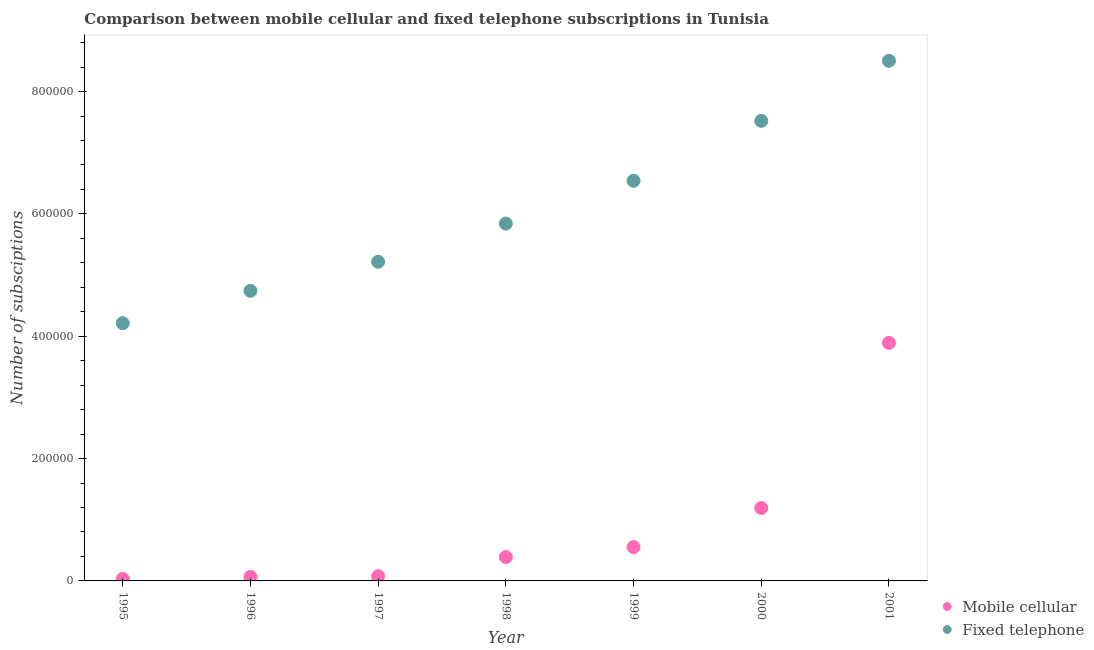What is the number of mobile cellular subscriptions in 1995?
Provide a short and direct response. 3185. Across all years, what is the maximum number of fixed telephone subscriptions?
Provide a succinct answer. 8.50e+05. Across all years, what is the minimum number of fixed telephone subscriptions?
Ensure brevity in your answer.  4.21e+05. In which year was the number of mobile cellular subscriptions minimum?
Your answer should be compact. 1995. What is the total number of fixed telephone subscriptions in the graph?
Make the answer very short. 4.26e+06. What is the difference between the number of mobile cellular subscriptions in 1998 and that in 2001?
Provide a short and direct response. -3.50e+05. What is the difference between the number of fixed telephone subscriptions in 1997 and the number of mobile cellular subscriptions in 1998?
Your answer should be compact. 4.83e+05. What is the average number of mobile cellular subscriptions per year?
Offer a very short reply. 8.86e+04. In the year 2000, what is the difference between the number of fixed telephone subscriptions and number of mobile cellular subscriptions?
Provide a succinct answer. 6.33e+05. In how many years, is the number of fixed telephone subscriptions greater than 200000?
Your answer should be very brief. 7. What is the ratio of the number of fixed telephone subscriptions in 1997 to that in 2000?
Your answer should be compact. 0.69. Is the number of mobile cellular subscriptions in 1997 less than that in 1998?
Give a very brief answer. Yes. Is the difference between the number of mobile cellular subscriptions in 1995 and 2000 greater than the difference between the number of fixed telephone subscriptions in 1995 and 2000?
Your response must be concise. Yes. What is the difference between the highest and the second highest number of fixed telephone subscriptions?
Keep it short and to the point. 9.82e+04. What is the difference between the highest and the lowest number of mobile cellular subscriptions?
Your answer should be very brief. 3.86e+05. Is the sum of the number of mobile cellular subscriptions in 1995 and 2001 greater than the maximum number of fixed telephone subscriptions across all years?
Provide a short and direct response. No. Does the graph contain grids?
Provide a succinct answer. No. Where does the legend appear in the graph?
Offer a terse response. Bottom right. What is the title of the graph?
Offer a terse response. Comparison between mobile cellular and fixed telephone subscriptions in Tunisia. Does "Services" appear as one of the legend labels in the graph?
Provide a succinct answer. No. What is the label or title of the Y-axis?
Keep it short and to the point. Number of subsciptions. What is the Number of subsciptions in Mobile cellular in 1995?
Provide a succinct answer. 3185. What is the Number of subsciptions in Fixed telephone in 1995?
Your response must be concise. 4.21e+05. What is the Number of subsciptions of Mobile cellular in 1996?
Keep it short and to the point. 6500. What is the Number of subsciptions of Fixed telephone in 1996?
Keep it short and to the point. 4.74e+05. What is the Number of subsciptions of Mobile cellular in 1997?
Make the answer very short. 7656. What is the Number of subsciptions of Fixed telephone in 1997?
Keep it short and to the point. 5.22e+05. What is the Number of subsciptions of Mobile cellular in 1998?
Provide a short and direct response. 3.90e+04. What is the Number of subsciptions in Fixed telephone in 1998?
Ensure brevity in your answer.  5.84e+05. What is the Number of subsciptions in Mobile cellular in 1999?
Ensure brevity in your answer.  5.53e+04. What is the Number of subsciptions of Fixed telephone in 1999?
Your response must be concise. 6.54e+05. What is the Number of subsciptions in Mobile cellular in 2000?
Offer a very short reply. 1.19e+05. What is the Number of subsciptions in Fixed telephone in 2000?
Your answer should be very brief. 7.52e+05. What is the Number of subsciptions in Mobile cellular in 2001?
Ensure brevity in your answer.  3.89e+05. What is the Number of subsciptions in Fixed telephone in 2001?
Keep it short and to the point. 8.50e+05. Across all years, what is the maximum Number of subsciptions of Mobile cellular?
Your response must be concise. 3.89e+05. Across all years, what is the maximum Number of subsciptions in Fixed telephone?
Offer a terse response. 8.50e+05. Across all years, what is the minimum Number of subsciptions of Mobile cellular?
Make the answer very short. 3185. Across all years, what is the minimum Number of subsciptions in Fixed telephone?
Your answer should be very brief. 4.21e+05. What is the total Number of subsciptions of Mobile cellular in the graph?
Provide a short and direct response. 6.20e+05. What is the total Number of subsciptions of Fixed telephone in the graph?
Provide a short and direct response. 4.26e+06. What is the difference between the Number of subsciptions in Mobile cellular in 1995 and that in 1996?
Your response must be concise. -3315. What is the difference between the Number of subsciptions of Fixed telephone in 1995 and that in 1996?
Your answer should be compact. -5.29e+04. What is the difference between the Number of subsciptions of Mobile cellular in 1995 and that in 1997?
Your response must be concise. -4471. What is the difference between the Number of subsciptions of Fixed telephone in 1995 and that in 1997?
Give a very brief answer. -1.00e+05. What is the difference between the Number of subsciptions in Mobile cellular in 1995 and that in 1998?
Ensure brevity in your answer.  -3.58e+04. What is the difference between the Number of subsciptions of Fixed telephone in 1995 and that in 1998?
Give a very brief answer. -1.63e+05. What is the difference between the Number of subsciptions of Mobile cellular in 1995 and that in 1999?
Keep it short and to the point. -5.21e+04. What is the difference between the Number of subsciptions in Fixed telephone in 1995 and that in 1999?
Offer a terse response. -2.33e+05. What is the difference between the Number of subsciptions of Mobile cellular in 1995 and that in 2000?
Ensure brevity in your answer.  -1.16e+05. What is the difference between the Number of subsciptions of Fixed telephone in 1995 and that in 2000?
Provide a succinct answer. -3.31e+05. What is the difference between the Number of subsciptions in Mobile cellular in 1995 and that in 2001?
Your response must be concise. -3.86e+05. What is the difference between the Number of subsciptions of Fixed telephone in 1995 and that in 2001?
Your response must be concise. -4.29e+05. What is the difference between the Number of subsciptions in Mobile cellular in 1996 and that in 1997?
Offer a very short reply. -1156. What is the difference between the Number of subsciptions of Fixed telephone in 1996 and that in 1997?
Your response must be concise. -4.75e+04. What is the difference between the Number of subsciptions in Mobile cellular in 1996 and that in 1998?
Ensure brevity in your answer.  -3.25e+04. What is the difference between the Number of subsciptions of Fixed telephone in 1996 and that in 1998?
Provide a succinct answer. -1.10e+05. What is the difference between the Number of subsciptions of Mobile cellular in 1996 and that in 1999?
Keep it short and to the point. -4.88e+04. What is the difference between the Number of subsciptions of Fixed telephone in 1996 and that in 1999?
Your answer should be compact. -1.80e+05. What is the difference between the Number of subsciptions of Mobile cellular in 1996 and that in 2000?
Provide a short and direct response. -1.13e+05. What is the difference between the Number of subsciptions of Fixed telephone in 1996 and that in 2000?
Offer a terse response. -2.78e+05. What is the difference between the Number of subsciptions of Mobile cellular in 1996 and that in 2001?
Make the answer very short. -3.83e+05. What is the difference between the Number of subsciptions of Fixed telephone in 1996 and that in 2001?
Keep it short and to the point. -3.76e+05. What is the difference between the Number of subsciptions of Mobile cellular in 1997 and that in 1998?
Provide a short and direct response. -3.13e+04. What is the difference between the Number of subsciptions of Fixed telephone in 1997 and that in 1998?
Your answer should be very brief. -6.25e+04. What is the difference between the Number of subsciptions of Mobile cellular in 1997 and that in 1999?
Your answer should be compact. -4.76e+04. What is the difference between the Number of subsciptions of Fixed telephone in 1997 and that in 1999?
Provide a short and direct response. -1.32e+05. What is the difference between the Number of subsciptions of Mobile cellular in 1997 and that in 2000?
Keep it short and to the point. -1.12e+05. What is the difference between the Number of subsciptions in Fixed telephone in 1997 and that in 2000?
Keep it short and to the point. -2.30e+05. What is the difference between the Number of subsciptions in Mobile cellular in 1997 and that in 2001?
Give a very brief answer. -3.82e+05. What is the difference between the Number of subsciptions in Fixed telephone in 1997 and that in 2001?
Your answer should be very brief. -3.29e+05. What is the difference between the Number of subsciptions of Mobile cellular in 1998 and that in 1999?
Provide a short and direct response. -1.63e+04. What is the difference between the Number of subsciptions in Fixed telephone in 1998 and that in 1999?
Offer a very short reply. -7.00e+04. What is the difference between the Number of subsciptions in Mobile cellular in 1998 and that in 2000?
Make the answer very short. -8.02e+04. What is the difference between the Number of subsciptions in Fixed telephone in 1998 and that in 2000?
Your response must be concise. -1.68e+05. What is the difference between the Number of subsciptions of Mobile cellular in 1998 and that in 2001?
Provide a succinct answer. -3.50e+05. What is the difference between the Number of subsciptions in Fixed telephone in 1998 and that in 2001?
Provide a short and direct response. -2.66e+05. What is the difference between the Number of subsciptions in Mobile cellular in 1999 and that in 2000?
Your answer should be compact. -6.39e+04. What is the difference between the Number of subsciptions in Fixed telephone in 1999 and that in 2000?
Provide a short and direct response. -9.79e+04. What is the difference between the Number of subsciptions of Mobile cellular in 1999 and that in 2001?
Your answer should be compact. -3.34e+05. What is the difference between the Number of subsciptions in Fixed telephone in 1999 and that in 2001?
Offer a very short reply. -1.96e+05. What is the difference between the Number of subsciptions of Mobile cellular in 2000 and that in 2001?
Your response must be concise. -2.70e+05. What is the difference between the Number of subsciptions of Fixed telephone in 2000 and that in 2001?
Offer a very short reply. -9.82e+04. What is the difference between the Number of subsciptions of Mobile cellular in 1995 and the Number of subsciptions of Fixed telephone in 1996?
Give a very brief answer. -4.71e+05. What is the difference between the Number of subsciptions in Mobile cellular in 1995 and the Number of subsciptions in Fixed telephone in 1997?
Keep it short and to the point. -5.19e+05. What is the difference between the Number of subsciptions of Mobile cellular in 1995 and the Number of subsciptions of Fixed telephone in 1998?
Offer a terse response. -5.81e+05. What is the difference between the Number of subsciptions in Mobile cellular in 1995 and the Number of subsciptions in Fixed telephone in 1999?
Offer a very short reply. -6.51e+05. What is the difference between the Number of subsciptions in Mobile cellular in 1995 and the Number of subsciptions in Fixed telephone in 2000?
Give a very brief answer. -7.49e+05. What is the difference between the Number of subsciptions in Mobile cellular in 1995 and the Number of subsciptions in Fixed telephone in 2001?
Your answer should be very brief. -8.47e+05. What is the difference between the Number of subsciptions of Mobile cellular in 1996 and the Number of subsciptions of Fixed telephone in 1997?
Offer a terse response. -5.15e+05. What is the difference between the Number of subsciptions in Mobile cellular in 1996 and the Number of subsciptions in Fixed telephone in 1998?
Offer a terse response. -5.78e+05. What is the difference between the Number of subsciptions of Mobile cellular in 1996 and the Number of subsciptions of Fixed telephone in 1999?
Keep it short and to the point. -6.48e+05. What is the difference between the Number of subsciptions of Mobile cellular in 1996 and the Number of subsciptions of Fixed telephone in 2000?
Give a very brief answer. -7.46e+05. What is the difference between the Number of subsciptions of Mobile cellular in 1996 and the Number of subsciptions of Fixed telephone in 2001?
Give a very brief answer. -8.44e+05. What is the difference between the Number of subsciptions in Mobile cellular in 1997 and the Number of subsciptions in Fixed telephone in 1998?
Offer a terse response. -5.77e+05. What is the difference between the Number of subsciptions in Mobile cellular in 1997 and the Number of subsciptions in Fixed telephone in 1999?
Make the answer very short. -6.47e+05. What is the difference between the Number of subsciptions in Mobile cellular in 1997 and the Number of subsciptions in Fixed telephone in 2000?
Give a very brief answer. -7.45e+05. What is the difference between the Number of subsciptions in Mobile cellular in 1997 and the Number of subsciptions in Fixed telephone in 2001?
Your answer should be compact. -8.43e+05. What is the difference between the Number of subsciptions of Mobile cellular in 1998 and the Number of subsciptions of Fixed telephone in 1999?
Your response must be concise. -6.15e+05. What is the difference between the Number of subsciptions in Mobile cellular in 1998 and the Number of subsciptions in Fixed telephone in 2000?
Offer a very short reply. -7.13e+05. What is the difference between the Number of subsciptions of Mobile cellular in 1998 and the Number of subsciptions of Fixed telephone in 2001?
Your answer should be compact. -8.11e+05. What is the difference between the Number of subsciptions in Mobile cellular in 1999 and the Number of subsciptions in Fixed telephone in 2000?
Your answer should be compact. -6.97e+05. What is the difference between the Number of subsciptions of Mobile cellular in 1999 and the Number of subsciptions of Fixed telephone in 2001?
Give a very brief answer. -7.95e+05. What is the difference between the Number of subsciptions in Mobile cellular in 2000 and the Number of subsciptions in Fixed telephone in 2001?
Give a very brief answer. -7.31e+05. What is the average Number of subsciptions in Mobile cellular per year?
Your answer should be compact. 8.86e+04. What is the average Number of subsciptions in Fixed telephone per year?
Your answer should be compact. 6.08e+05. In the year 1995, what is the difference between the Number of subsciptions in Mobile cellular and Number of subsciptions in Fixed telephone?
Provide a succinct answer. -4.18e+05. In the year 1996, what is the difference between the Number of subsciptions of Mobile cellular and Number of subsciptions of Fixed telephone?
Your answer should be very brief. -4.68e+05. In the year 1997, what is the difference between the Number of subsciptions in Mobile cellular and Number of subsciptions in Fixed telephone?
Provide a succinct answer. -5.14e+05. In the year 1998, what is the difference between the Number of subsciptions in Mobile cellular and Number of subsciptions in Fixed telephone?
Ensure brevity in your answer.  -5.45e+05. In the year 1999, what is the difference between the Number of subsciptions in Mobile cellular and Number of subsciptions in Fixed telephone?
Give a very brief answer. -5.99e+05. In the year 2000, what is the difference between the Number of subsciptions of Mobile cellular and Number of subsciptions of Fixed telephone?
Provide a short and direct response. -6.33e+05. In the year 2001, what is the difference between the Number of subsciptions in Mobile cellular and Number of subsciptions in Fixed telephone?
Make the answer very short. -4.61e+05. What is the ratio of the Number of subsciptions in Mobile cellular in 1995 to that in 1996?
Offer a very short reply. 0.49. What is the ratio of the Number of subsciptions of Fixed telephone in 1995 to that in 1996?
Offer a terse response. 0.89. What is the ratio of the Number of subsciptions of Mobile cellular in 1995 to that in 1997?
Ensure brevity in your answer.  0.42. What is the ratio of the Number of subsciptions in Fixed telephone in 1995 to that in 1997?
Your response must be concise. 0.81. What is the ratio of the Number of subsciptions of Mobile cellular in 1995 to that in 1998?
Give a very brief answer. 0.08. What is the ratio of the Number of subsciptions in Fixed telephone in 1995 to that in 1998?
Your response must be concise. 0.72. What is the ratio of the Number of subsciptions in Mobile cellular in 1995 to that in 1999?
Offer a terse response. 0.06. What is the ratio of the Number of subsciptions of Fixed telephone in 1995 to that in 1999?
Give a very brief answer. 0.64. What is the ratio of the Number of subsciptions of Mobile cellular in 1995 to that in 2000?
Your answer should be very brief. 0.03. What is the ratio of the Number of subsciptions in Fixed telephone in 1995 to that in 2000?
Keep it short and to the point. 0.56. What is the ratio of the Number of subsciptions in Mobile cellular in 1995 to that in 2001?
Keep it short and to the point. 0.01. What is the ratio of the Number of subsciptions in Fixed telephone in 1995 to that in 2001?
Offer a terse response. 0.5. What is the ratio of the Number of subsciptions of Mobile cellular in 1996 to that in 1997?
Your answer should be compact. 0.85. What is the ratio of the Number of subsciptions in Fixed telephone in 1996 to that in 1997?
Keep it short and to the point. 0.91. What is the ratio of the Number of subsciptions in Fixed telephone in 1996 to that in 1998?
Provide a succinct answer. 0.81. What is the ratio of the Number of subsciptions in Mobile cellular in 1996 to that in 1999?
Keep it short and to the point. 0.12. What is the ratio of the Number of subsciptions in Fixed telephone in 1996 to that in 1999?
Keep it short and to the point. 0.72. What is the ratio of the Number of subsciptions in Mobile cellular in 1996 to that in 2000?
Provide a succinct answer. 0.05. What is the ratio of the Number of subsciptions of Fixed telephone in 1996 to that in 2000?
Ensure brevity in your answer.  0.63. What is the ratio of the Number of subsciptions in Mobile cellular in 1996 to that in 2001?
Keep it short and to the point. 0.02. What is the ratio of the Number of subsciptions in Fixed telephone in 1996 to that in 2001?
Keep it short and to the point. 0.56. What is the ratio of the Number of subsciptions in Mobile cellular in 1997 to that in 1998?
Keep it short and to the point. 0.2. What is the ratio of the Number of subsciptions of Fixed telephone in 1997 to that in 1998?
Your answer should be compact. 0.89. What is the ratio of the Number of subsciptions of Mobile cellular in 1997 to that in 1999?
Provide a succinct answer. 0.14. What is the ratio of the Number of subsciptions in Fixed telephone in 1997 to that in 1999?
Ensure brevity in your answer.  0.8. What is the ratio of the Number of subsciptions in Mobile cellular in 1997 to that in 2000?
Your response must be concise. 0.06. What is the ratio of the Number of subsciptions of Fixed telephone in 1997 to that in 2000?
Ensure brevity in your answer.  0.69. What is the ratio of the Number of subsciptions in Mobile cellular in 1997 to that in 2001?
Offer a terse response. 0.02. What is the ratio of the Number of subsciptions in Fixed telephone in 1997 to that in 2001?
Your answer should be compact. 0.61. What is the ratio of the Number of subsciptions in Mobile cellular in 1998 to that in 1999?
Offer a terse response. 0.71. What is the ratio of the Number of subsciptions of Fixed telephone in 1998 to that in 1999?
Provide a short and direct response. 0.89. What is the ratio of the Number of subsciptions of Mobile cellular in 1998 to that in 2000?
Offer a terse response. 0.33. What is the ratio of the Number of subsciptions in Fixed telephone in 1998 to that in 2000?
Make the answer very short. 0.78. What is the ratio of the Number of subsciptions in Mobile cellular in 1998 to that in 2001?
Offer a terse response. 0.1. What is the ratio of the Number of subsciptions of Fixed telephone in 1998 to that in 2001?
Provide a succinct answer. 0.69. What is the ratio of the Number of subsciptions in Mobile cellular in 1999 to that in 2000?
Your answer should be compact. 0.46. What is the ratio of the Number of subsciptions of Fixed telephone in 1999 to that in 2000?
Your answer should be compact. 0.87. What is the ratio of the Number of subsciptions in Mobile cellular in 1999 to that in 2001?
Provide a succinct answer. 0.14. What is the ratio of the Number of subsciptions of Fixed telephone in 1999 to that in 2001?
Ensure brevity in your answer.  0.77. What is the ratio of the Number of subsciptions in Mobile cellular in 2000 to that in 2001?
Your answer should be compact. 0.31. What is the ratio of the Number of subsciptions of Fixed telephone in 2000 to that in 2001?
Provide a short and direct response. 0.88. What is the difference between the highest and the second highest Number of subsciptions of Mobile cellular?
Keep it short and to the point. 2.70e+05. What is the difference between the highest and the second highest Number of subsciptions of Fixed telephone?
Ensure brevity in your answer.  9.82e+04. What is the difference between the highest and the lowest Number of subsciptions in Mobile cellular?
Your answer should be compact. 3.86e+05. What is the difference between the highest and the lowest Number of subsciptions in Fixed telephone?
Your response must be concise. 4.29e+05. 